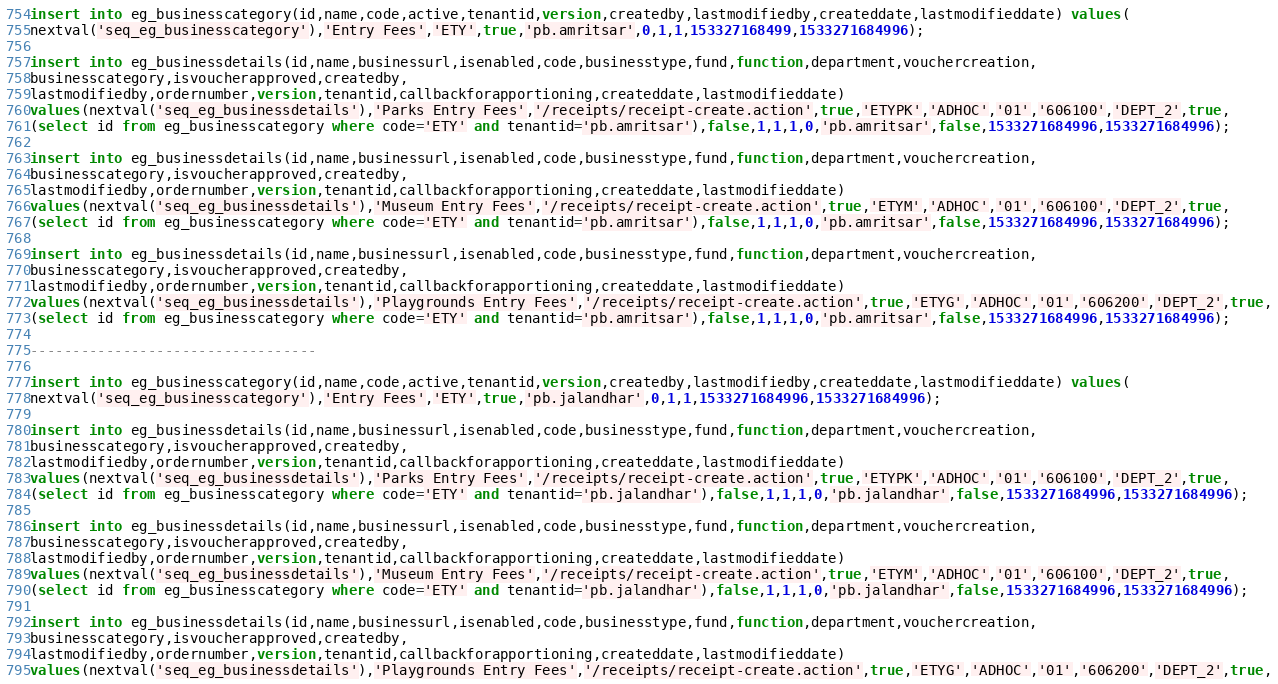Convert code to text. <code><loc_0><loc_0><loc_500><loc_500><_SQL_>insert into eg_businesscategory(id,name,code,active,tenantid,version,createdby,lastmodifiedby,createddate,lastmodifieddate) values(
nextval('seq_eg_businesscategory'),'Entry Fees','ETY',true,'pb.amritsar',0,1,1,153327168499,1533271684996);

insert into eg_businessdetails(id,name,businessurl,isenabled,code,businesstype,fund,function,department,vouchercreation,
businesscategory,isvoucherapproved,createdby,
lastmodifiedby,ordernumber,version,tenantid,callbackforapportioning,createddate,lastmodifieddate)
values(nextval('seq_eg_businessdetails'),'Parks Entry Fees','/receipts/receipt-create.action',true,'ETYPK','ADHOC','01','606100','DEPT_2',true,
(select id from eg_businesscategory where code='ETY' and tenantid='pb.amritsar'),false,1,1,1,0,'pb.amritsar',false,1533271684996,1533271684996);

insert into eg_businessdetails(id,name,businessurl,isenabled,code,businesstype,fund,function,department,vouchercreation,
businesscategory,isvoucherapproved,createdby,
lastmodifiedby,ordernumber,version,tenantid,callbackforapportioning,createddate,lastmodifieddate)
values(nextval('seq_eg_businessdetails'),'Museum Entry Fees','/receipts/receipt-create.action',true,'ETYM','ADHOC','01','606100','DEPT_2',true,
(select id from eg_businesscategory where code='ETY' and tenantid='pb.amritsar'),false,1,1,1,0,'pb.amritsar',false,1533271684996,1533271684996);

insert into eg_businessdetails(id,name,businessurl,isenabled,code,businesstype,fund,function,department,vouchercreation,
businesscategory,isvoucherapproved,createdby,
lastmodifiedby,ordernumber,version,tenantid,callbackforapportioning,createddate,lastmodifieddate)
values(nextval('seq_eg_businessdetails'),'Playgrounds Entry Fees','/receipts/receipt-create.action',true,'ETYG','ADHOC','01','606200','DEPT_2',true,
(select id from eg_businesscategory where code='ETY' and tenantid='pb.amritsar'),false,1,1,1,0,'pb.amritsar',false,1533271684996,1533271684996);

----------------------------------

insert into eg_businesscategory(id,name,code,active,tenantid,version,createdby,lastmodifiedby,createddate,lastmodifieddate) values(
nextval('seq_eg_businesscategory'),'Entry Fees','ETY',true,'pb.jalandhar',0,1,1,1533271684996,1533271684996);

insert into eg_businessdetails(id,name,businessurl,isenabled,code,businesstype,fund,function,department,vouchercreation,
businesscategory,isvoucherapproved,createdby,
lastmodifiedby,ordernumber,version,tenantid,callbackforapportioning,createddate,lastmodifieddate)
values(nextval('seq_eg_businessdetails'),'Parks Entry Fees','/receipts/receipt-create.action',true,'ETYPK','ADHOC','01','606100','DEPT_2',true,
(select id from eg_businesscategory where code='ETY' and tenantid='pb.jalandhar'),false,1,1,1,0,'pb.jalandhar',false,1533271684996,1533271684996);

insert into eg_businessdetails(id,name,businessurl,isenabled,code,businesstype,fund,function,department,vouchercreation,
businesscategory,isvoucherapproved,createdby,
lastmodifiedby,ordernumber,version,tenantid,callbackforapportioning,createddate,lastmodifieddate)
values(nextval('seq_eg_businessdetails'),'Museum Entry Fees','/receipts/receipt-create.action',true,'ETYM','ADHOC','01','606100','DEPT_2',true,
(select id from eg_businesscategory where code='ETY' and tenantid='pb.jalandhar'),false,1,1,1,0,'pb.jalandhar',false,1533271684996,1533271684996);

insert into eg_businessdetails(id,name,businessurl,isenabled,code,businesstype,fund,function,department,vouchercreation,
businesscategory,isvoucherapproved,createdby,
lastmodifiedby,ordernumber,version,tenantid,callbackforapportioning,createddate,lastmodifieddate)
values(nextval('seq_eg_businessdetails'),'Playgrounds Entry Fees','/receipts/receipt-create.action',true,'ETYG','ADHOC','01','606200','DEPT_2',true,</code> 